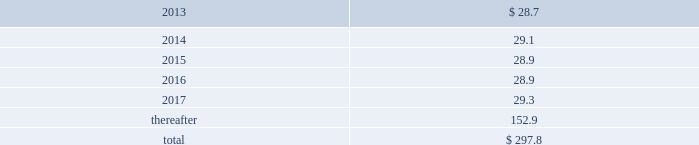Do so , cme invests such contributions in assets that mirror the assumed investment choices .
The balances in these plans are subject to the claims of general creditors of the exchange and totaled $ 38.7 million and $ 31.8 million at december 31 , 2012 and 2011 respectively .
Although the value of the plans is recorded as an asset in marketable securities in the consolidated balance sheets , there is an equal and offsetting liability .
The investment results of these plans have no impact on net income as the investment results are recorded in equal amounts to both investment income and compensation and benefits expense .
Supplemental savings plan .
Cme maintains a supplemental plan to provide benefits for employees who have been impacted by statutory limits under the provisions of the qualified pension and savings plan .
Employees in this plan are subject to the vesting requirements of the underlying qualified plans .
Deferred compensation plan .
A deferred compensation plan is maintained by cme , under which eligible officers and members of the board of directors may contribute a percentage of their compensation and defer income taxes thereon until the time of distribution .
Comex members 2019 retirement plan and benefits .
Comex maintains a retirement and benefit plan under the comex members 2019 recognition and retention plan ( mrrp ) .
This plan provides benefits to certain members of the comex division based on long-term membership , and participation is limited to individuals who were comex division members prior to nymex 2019s acquisition of comex in 1994 .
No new participants were permitted into the plan after the date of this acquisition .
Under the terms of the mrrp , the company is required to fund the plan with a minimum annual contribution of $ 0.8 million until it is fully funded .
All benefits to be paid under the mrrp are based on reasonable actuarial assumptions which are based upon the amounts that are available and are expected to be available to pay benefits .
Total contributions to the plan were $ 0.8 million for each of 2010 through 2012 .
At december 31 , 2012 and 2011 , the obligation for the mrrp totaled $ 22.7 million and $ 21.6 million , respectively .
Assets with a fair value of $ 18.4 million and $ 17.7 million have been allocated to this plan at december 31 , 2012 and 2011 , respectively , and are included in marketable securities and cash and cash equivalents in the consolidated balance sheets .
The balances in these plans are subject to the claims of general creditors of comex .
13 .
Commitments operating leases .
Cme group has entered into various non-cancellable operating lease agreements , with the most significant being as follows : 2022 in april 2012 , the company sold two buildings in chicago at 141 w .
Jackson and leased back a portion of the property .
The operating lease , which has an initial lease term ending on april 30 , 2027 , contains four consecutive renewal options for five years .
2022 in january 2011 , the company entered into an operating lease for office space in london .
The initial lease term , which became effective on january 20 , 2011 , terminates on march 24 , 2026 , with an option to terminate without penalty in january 2021 .
2022 in july 2008 , the company renegotiated the operating lease for its headquarters at 20 south wacker drive in chicago .
The lease , which has an initial term ending on november 30 , 2022 , contains two consecutive renewal options for seven and ten years and a contraction option which allows the company to reduce its occupied space after november 30 , 2018 .
In addition , the company may exercise a lease expansion option in december 2017 .
2022 in august 2006 , the company entered into an operating lease for additional office space in chicago .
The initial lease term , which became effective on august 10 , 2006 , terminates on november 30 , 2023 .
The lease contains two 5-year renewal options beginning in 2023 .
At december 31 , 2012 , future minimum payments under non-cancellable operating leases were payable as follows ( in millions ) : .

At december 31 , 2012 , what was the percent of the future minimum payments under non-cancellable operating leases that was due in 2014? 
Computations: (29.1 / 297.8)
Answer: 0.09772. Do so , cme invests such contributions in assets that mirror the assumed investment choices .
The balances in these plans are subject to the claims of general creditors of the exchange and totaled $ 38.7 million and $ 31.8 million at december 31 , 2012 and 2011 respectively .
Although the value of the plans is recorded as an asset in marketable securities in the consolidated balance sheets , there is an equal and offsetting liability .
The investment results of these plans have no impact on net income as the investment results are recorded in equal amounts to both investment income and compensation and benefits expense .
Supplemental savings plan .
Cme maintains a supplemental plan to provide benefits for employees who have been impacted by statutory limits under the provisions of the qualified pension and savings plan .
Employees in this plan are subject to the vesting requirements of the underlying qualified plans .
Deferred compensation plan .
A deferred compensation plan is maintained by cme , under which eligible officers and members of the board of directors may contribute a percentage of their compensation and defer income taxes thereon until the time of distribution .
Comex members 2019 retirement plan and benefits .
Comex maintains a retirement and benefit plan under the comex members 2019 recognition and retention plan ( mrrp ) .
This plan provides benefits to certain members of the comex division based on long-term membership , and participation is limited to individuals who were comex division members prior to nymex 2019s acquisition of comex in 1994 .
No new participants were permitted into the plan after the date of this acquisition .
Under the terms of the mrrp , the company is required to fund the plan with a minimum annual contribution of $ 0.8 million until it is fully funded .
All benefits to be paid under the mrrp are based on reasonable actuarial assumptions which are based upon the amounts that are available and are expected to be available to pay benefits .
Total contributions to the plan were $ 0.8 million for each of 2010 through 2012 .
At december 31 , 2012 and 2011 , the obligation for the mrrp totaled $ 22.7 million and $ 21.6 million , respectively .
Assets with a fair value of $ 18.4 million and $ 17.7 million have been allocated to this plan at december 31 , 2012 and 2011 , respectively , and are included in marketable securities and cash and cash equivalents in the consolidated balance sheets .
The balances in these plans are subject to the claims of general creditors of comex .
13 .
Commitments operating leases .
Cme group has entered into various non-cancellable operating lease agreements , with the most significant being as follows : 2022 in april 2012 , the company sold two buildings in chicago at 141 w .
Jackson and leased back a portion of the property .
The operating lease , which has an initial lease term ending on april 30 , 2027 , contains four consecutive renewal options for five years .
2022 in january 2011 , the company entered into an operating lease for office space in london .
The initial lease term , which became effective on january 20 , 2011 , terminates on march 24 , 2026 , with an option to terminate without penalty in january 2021 .
2022 in july 2008 , the company renegotiated the operating lease for its headquarters at 20 south wacker drive in chicago .
The lease , which has an initial term ending on november 30 , 2022 , contains two consecutive renewal options for seven and ten years and a contraction option which allows the company to reduce its occupied space after november 30 , 2018 .
In addition , the company may exercise a lease expansion option in december 2017 .
2022 in august 2006 , the company entered into an operating lease for additional office space in chicago .
The initial lease term , which became effective on august 10 , 2006 , terminates on november 30 , 2023 .
The lease contains two 5-year renewal options beginning in 2023 .
At december 31 , 2012 , future minimum payments under non-cancellable operating leases were payable as follows ( in millions ) : .

What portion of the future minimum payments are due in 2013? 
Computations: (28.7 / 297.8)
Answer: 0.09637. 